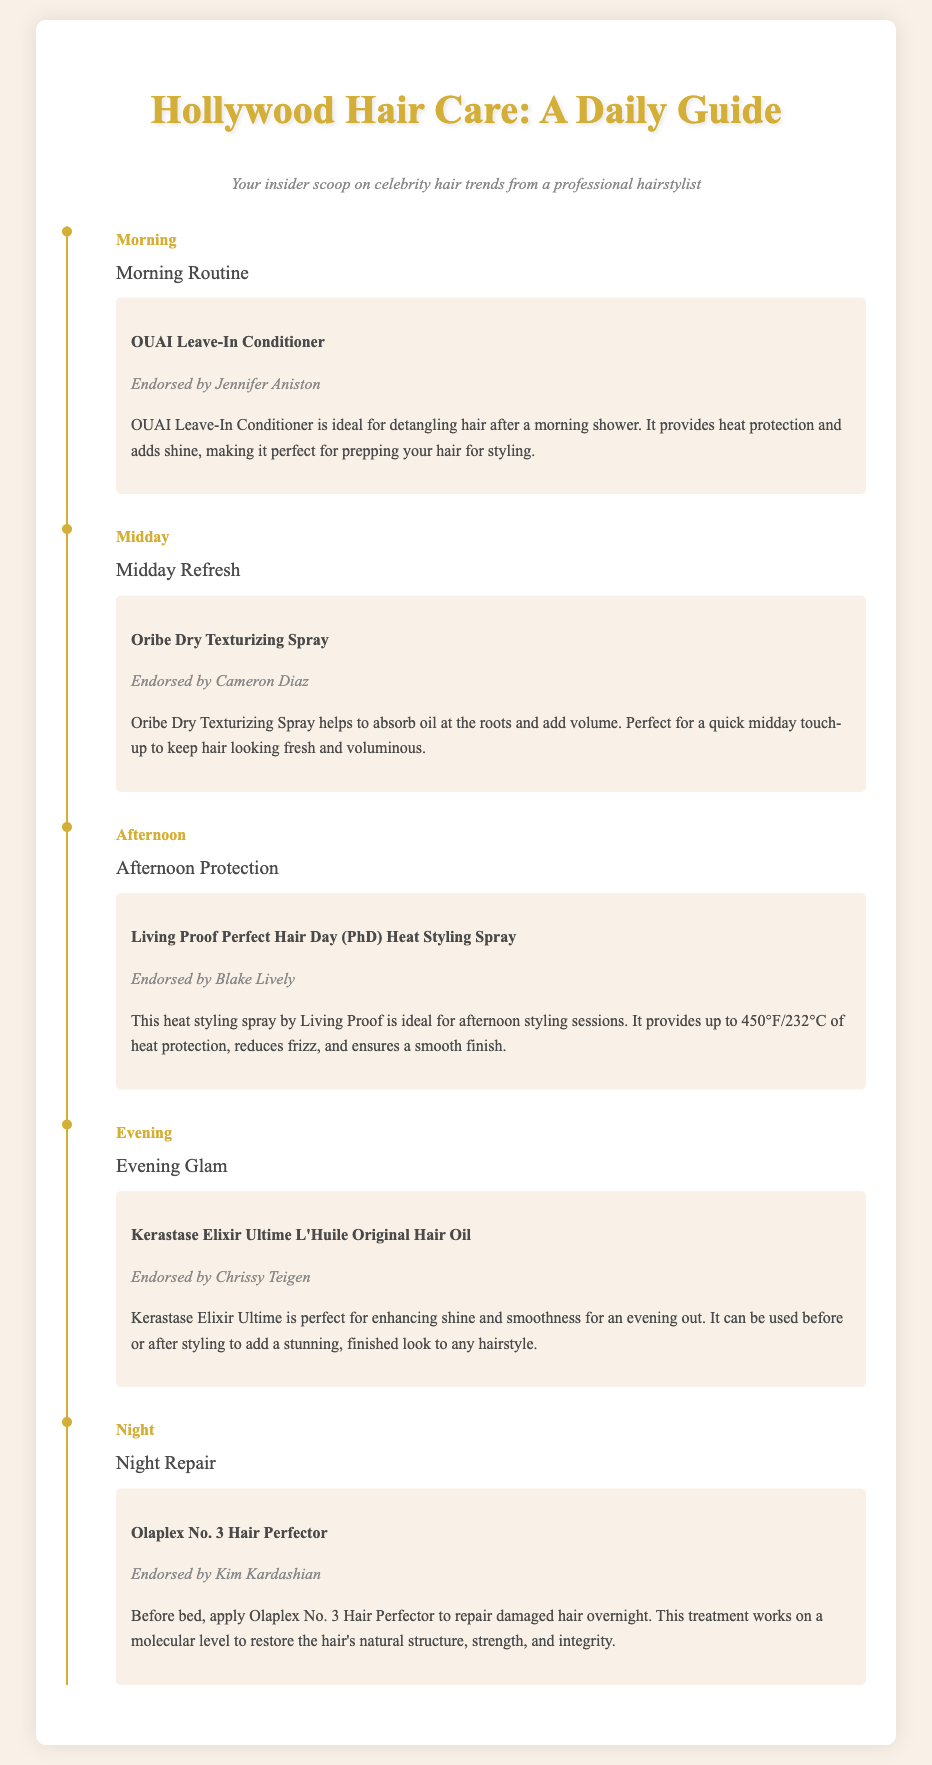what product is endorsed by Jennifer Aniston? The product listed in the morning routine endorsed by Jennifer Aniston is OUAI Leave-In Conditioner.
Answer: OUAI Leave-In Conditioner what time is dedicated to midday refresh? The document specifies the time for midday refresh as "Midday."
Answer: Midday which celebrity endorses Living Proof products? Living Proof Perfect Hair Day (PhD) Heat Styling Spray is endorsed by Blake Lively.
Answer: Blake Lively what is the purpose of Oribe Dry Texturizing Spray? Oribe Dry Texturizing Spray is used to absorb oil and add volume.
Answer: Absorb oil and add volume which product should be applied before bed? The product to be applied before bed for night repair is Olaplex No. 3 Hair Perfector.
Answer: Olaplex No. 3 Hair Perfector what type of product is Kerastase Elixir Ultime L'Huile Original Hair Oil? It is a hair oil used for enhancing shine and smoothness.
Answer: Hair oil what is the heat protection level of Living Proof's styling spray? Living Proof Perfect Hair Day (PhD) Heat Styling Spray provides up to 450°F/232°C of heat protection.
Answer: 450°F/232°C which evening product is endorsed by Chrissy Teigen? The product endorsed by Chrissy Teigen for evening glam is Kerastase Elixir Ultime L'Huile Original Hair Oil.
Answer: Kerastase Elixir Ultime L'Huile Original Hair Oil how often should you use Olaplex No. 3 Hair Perfector? The document implies it should be used before bed, suggesting regular use for repair.
Answer: Regularly 